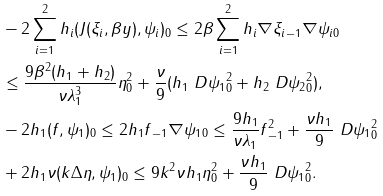<formula> <loc_0><loc_0><loc_500><loc_500>& - 2 \sum _ { i = 1 } ^ { 2 } h _ { i } ( J ( \xi _ { i } , \beta y ) , \psi _ { i } ) _ { 0 } \leq 2 \beta \sum _ { i = 1 } ^ { 2 } h _ { i } \| \nabla \xi _ { i } \| _ { - 1 } \| \nabla \psi _ { i } \| _ { 0 } \\ & \leq \frac { 9 \beta ^ { 2 } ( h _ { 1 } + h _ { 2 } ) } { \nu \lambda _ { 1 } ^ { 3 } } \| \eta \| _ { 0 } ^ { 2 } + \frac { \nu } { 9 } ( h _ { 1 } \| \ D \psi _ { 1 } \| _ { 0 } ^ { 2 } + h _ { 2 } \| \ D \psi _ { 2 } \| _ { 0 } ^ { 2 } ) , \\ & - 2 h _ { 1 } ( f , \psi _ { 1 } ) _ { 0 } \leq 2 h _ { 1 } \| f \| _ { - 1 } \| \nabla \psi _ { 1 } \| _ { 0 } \leq \frac { 9 h _ { 1 } } { \nu \lambda _ { 1 } } \| f \| _ { - 1 } ^ { 2 } + \frac { \nu h _ { 1 } } { 9 } \| \ D \psi _ { 1 } \| _ { 0 } ^ { 2 } \\ & + 2 h _ { 1 } \nu ( k \Delta \eta , \psi _ { 1 } ) _ { 0 } \leq 9 k ^ { 2 } \nu h _ { 1 } \| \eta \| _ { 0 } ^ { 2 } + \frac { \nu h _ { 1 } } { 9 } \| \ D \psi _ { 1 } \| _ { 0 } ^ { 2 } .</formula> 